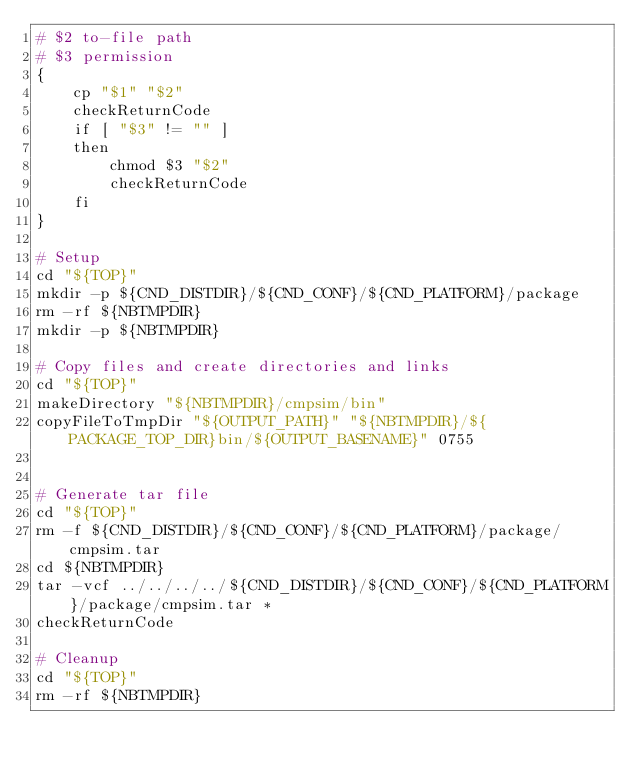<code> <loc_0><loc_0><loc_500><loc_500><_Bash_># $2 to-file path
# $3 permission
{
    cp "$1" "$2"
    checkReturnCode
    if [ "$3" != "" ]
    then
        chmod $3 "$2"
        checkReturnCode
    fi
}

# Setup
cd "${TOP}"
mkdir -p ${CND_DISTDIR}/${CND_CONF}/${CND_PLATFORM}/package
rm -rf ${NBTMPDIR}
mkdir -p ${NBTMPDIR}

# Copy files and create directories and links
cd "${TOP}"
makeDirectory "${NBTMPDIR}/cmpsim/bin"
copyFileToTmpDir "${OUTPUT_PATH}" "${NBTMPDIR}/${PACKAGE_TOP_DIR}bin/${OUTPUT_BASENAME}" 0755


# Generate tar file
cd "${TOP}"
rm -f ${CND_DISTDIR}/${CND_CONF}/${CND_PLATFORM}/package/cmpsim.tar
cd ${NBTMPDIR}
tar -vcf ../../../../${CND_DISTDIR}/${CND_CONF}/${CND_PLATFORM}/package/cmpsim.tar *
checkReturnCode

# Cleanup
cd "${TOP}"
rm -rf ${NBTMPDIR}
</code> 